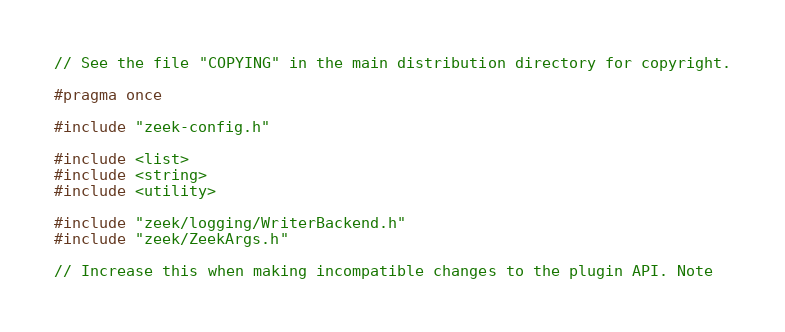<code> <loc_0><loc_0><loc_500><loc_500><_C_>// See the file "COPYING" in the main distribution directory for copyright.

#pragma once

#include "zeek-config.h"

#include <list>
#include <string>
#include <utility>

#include "zeek/logging/WriterBackend.h"
#include "zeek/ZeekArgs.h"

// Increase this when making incompatible changes to the plugin API. Note</code> 